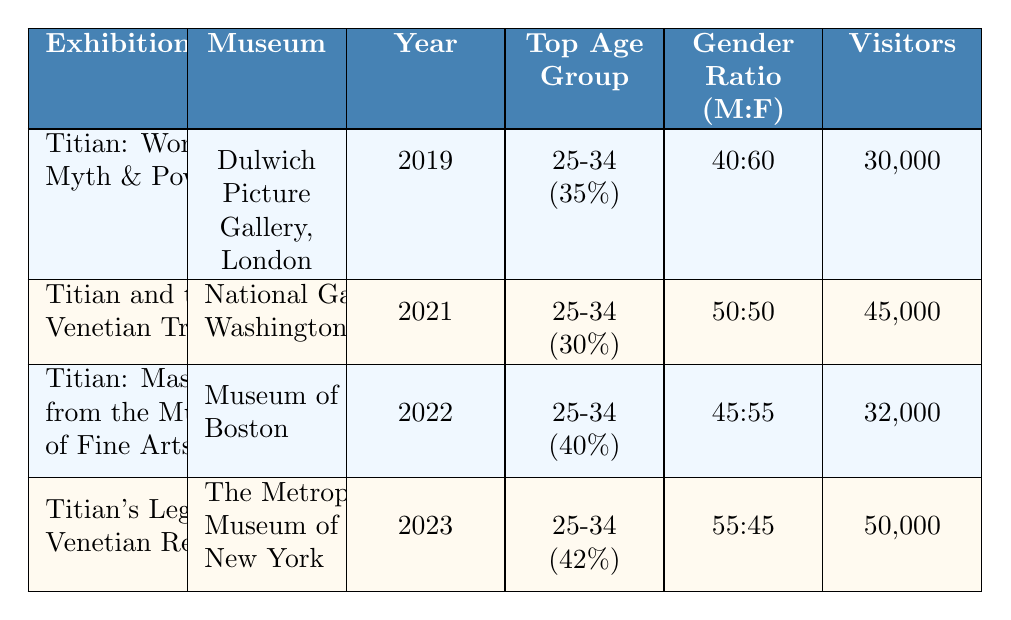What is the title of the exhibition held at the Dulwich Picture Gallery? The exhibition held at the Dulwich Picture Gallery is titled "Titian: Women, Myth & Power." This information can be found directly in the first row of the table under the "Exhibition" column.
Answer: Titian: Women, Myth & Power Which exhibition had the highest number of visitors? By examining the "Visitors" column, we see that "Titian's Legacy: Venetian Renaissance" at The Metropolitan Museum of Art had 50,000 visitors, which is higher than the others.
Answer: Titian's Legacy: Venetian Renaissance What is the gender ratio for the exhibition "Titian: Masterpieces from the Museum of Fine Arts"? The gender ratio listed in the table for that exhibition is 45:55, indicating 45% male and 55% female visitors. This data can be retrieved directly from the respective row in the table.
Answer: 45:55 What is the average number of visitors for all the exhibitions listed? To compute the average, we first add the total number of visitors: 30,000 + 45,000 + 32,000 + 50,000 = 157,000. Next, we divide this by the number of exhibitions (4): 157,000 / 4 = 39,250. Therefore, the average number of visitors is 39,250.
Answer: 39,250 Is the top age group for "Titian and the Venetian Tradition" younger than 35 years old? The top age group listed for that exhibition is 25-34 years old, which is indeed younger than 35. This confirmation comes directly from the "Top Age Group" column under the respective exhibition row.
Answer: Yes What is the total percentage of male visitors across all exhibitions? To find the total percentage of male visitors, we need to calculate the weighted average based on the number of visitors: (0.4 * 30,000 + 0.5 * 45,000 + 0.45 * 32,000 + 0.55 * 50,000) / 157,000. First, we find the male visitors: 12,000 + 22,500 + 14,400 + 27,500 = 76,400. Then, divide by the total visitors: 76,400 / 157,000 ≈ 0.487 or 48.7%. Therefore, the total percentage of male visitors is approximately 48.7%.
Answer: 48.7% Which exhibition had the highest percentage of young adult visitors (ages 18-24)? Looking at the "age_groups" data across exhibitions, "Titian: Masterpieces from the Museum of Fine Arts" had the highest percentage of young adult visitors at 25%. This percentage is directly found in the respective row under age groups.
Answer: Titian: Masterpieces from the Museum of Fine Arts Was the majority of visitors to "Titian: Women, Myth & Power" male? For this exhibition, the gender distribution shows 40% male and 60% female. Since 60% is greater than 40%, the majority of visitors were not male. This conclusion can be derived from the "gender_distribution" column.
Answer: No 